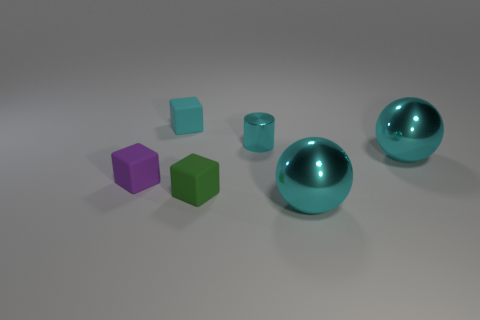Is there a matte block that is behind the cube that is right of the tiny block behind the tiny purple matte thing?
Your answer should be compact. Yes. What number of cylinders are cyan objects or big metallic objects?
Give a very brief answer. 1. There is a small cube on the right side of the small cyan rubber thing; what is its material?
Keep it short and to the point. Rubber. There is a cube that is the same color as the tiny metallic thing; what is its size?
Your answer should be compact. Small. There is a big shiny ball behind the purple matte object; is its color the same as the sphere in front of the green rubber object?
Make the answer very short. Yes. What number of objects are either cyan cubes or tiny gray metallic balls?
Make the answer very short. 1. How many other things are there of the same shape as the small purple matte thing?
Offer a terse response. 2. Are the small cyan thing behind the small cyan metal cylinder and the cyan cylinder to the right of the green rubber block made of the same material?
Keep it short and to the point. No. What is the shape of the small object that is both to the left of the green block and behind the purple rubber object?
Give a very brief answer. Cube. What material is the cube that is behind the tiny green thing and on the right side of the tiny purple matte object?
Provide a short and direct response. Rubber. 